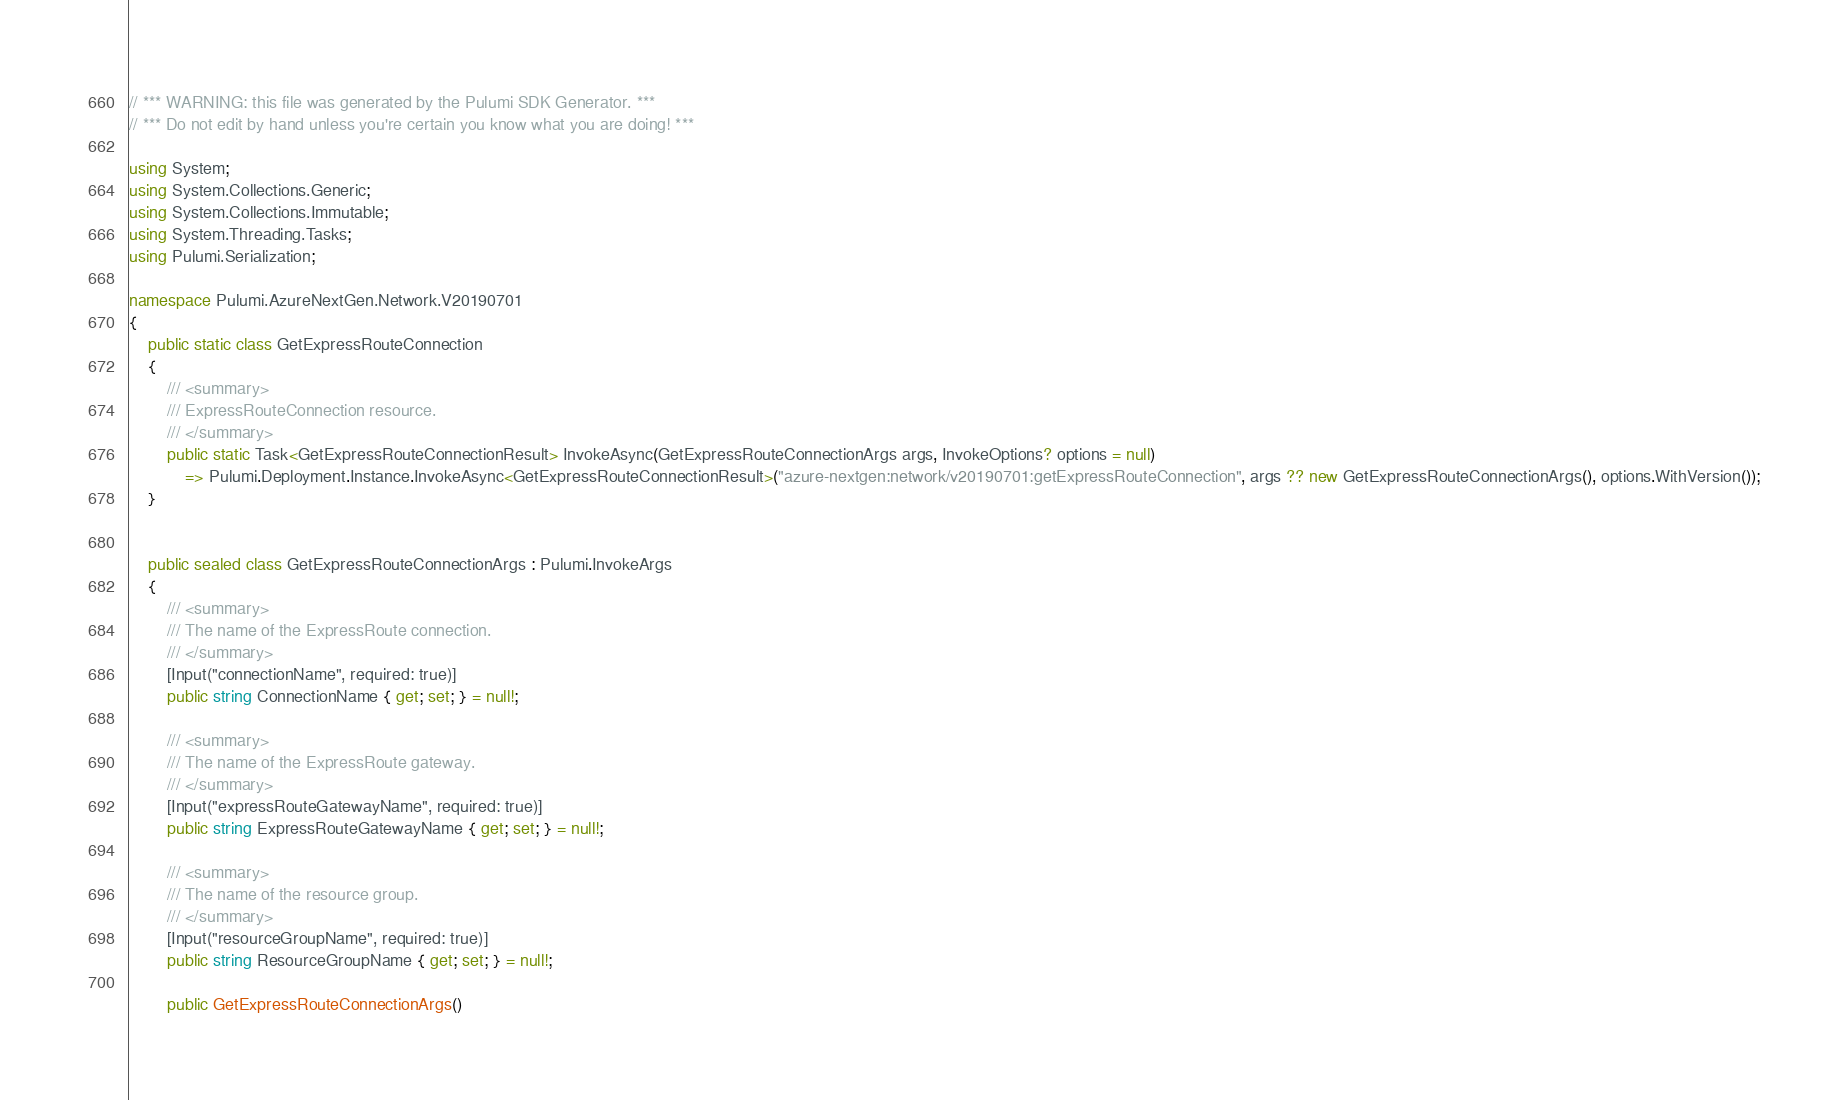<code> <loc_0><loc_0><loc_500><loc_500><_C#_>// *** WARNING: this file was generated by the Pulumi SDK Generator. ***
// *** Do not edit by hand unless you're certain you know what you are doing! ***

using System;
using System.Collections.Generic;
using System.Collections.Immutable;
using System.Threading.Tasks;
using Pulumi.Serialization;

namespace Pulumi.AzureNextGen.Network.V20190701
{
    public static class GetExpressRouteConnection
    {
        /// <summary>
        /// ExpressRouteConnection resource.
        /// </summary>
        public static Task<GetExpressRouteConnectionResult> InvokeAsync(GetExpressRouteConnectionArgs args, InvokeOptions? options = null)
            => Pulumi.Deployment.Instance.InvokeAsync<GetExpressRouteConnectionResult>("azure-nextgen:network/v20190701:getExpressRouteConnection", args ?? new GetExpressRouteConnectionArgs(), options.WithVersion());
    }


    public sealed class GetExpressRouteConnectionArgs : Pulumi.InvokeArgs
    {
        /// <summary>
        /// The name of the ExpressRoute connection.
        /// </summary>
        [Input("connectionName", required: true)]
        public string ConnectionName { get; set; } = null!;

        /// <summary>
        /// The name of the ExpressRoute gateway.
        /// </summary>
        [Input("expressRouteGatewayName", required: true)]
        public string ExpressRouteGatewayName { get; set; } = null!;

        /// <summary>
        /// The name of the resource group.
        /// </summary>
        [Input("resourceGroupName", required: true)]
        public string ResourceGroupName { get; set; } = null!;

        public GetExpressRouteConnectionArgs()</code> 